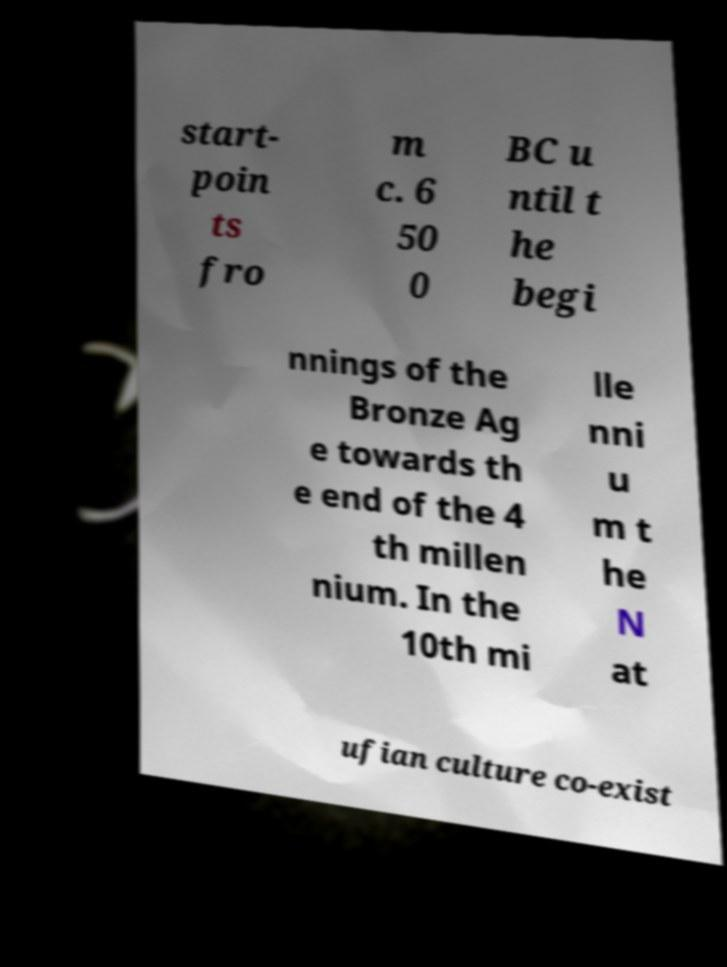For documentation purposes, I need the text within this image transcribed. Could you provide that? start- poin ts fro m c. 6 50 0 BC u ntil t he begi nnings of the Bronze Ag e towards th e end of the 4 th millen nium. In the 10th mi lle nni u m t he N at ufian culture co-exist 